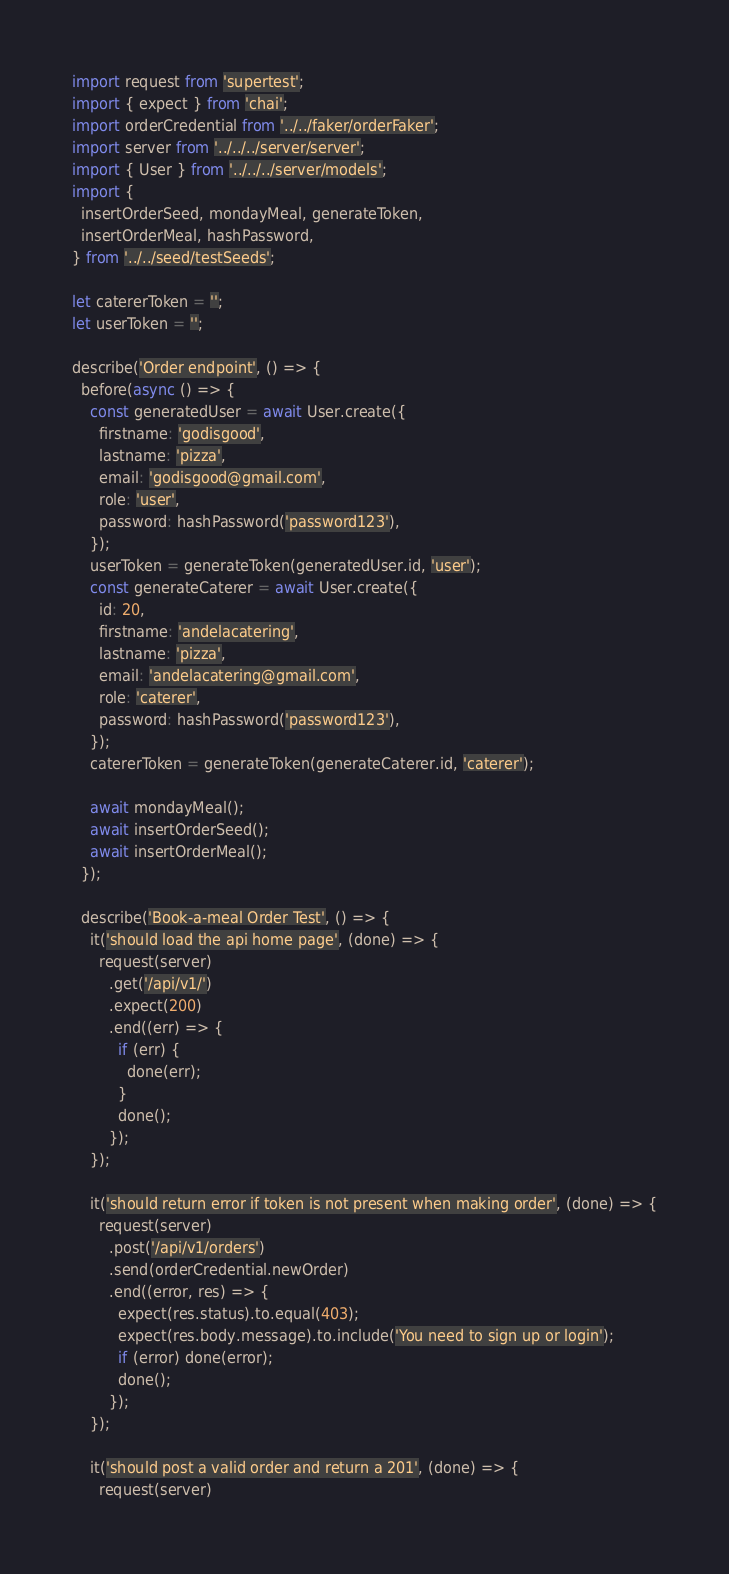<code> <loc_0><loc_0><loc_500><loc_500><_JavaScript_>import request from 'supertest';
import { expect } from 'chai';
import orderCredential from '../../faker/orderFaker';
import server from '../../../server/server';
import { User } from '../../../server/models';
import {
  insertOrderSeed, mondayMeal, generateToken,
  insertOrderMeal, hashPassword,
} from '../../seed/testSeeds';

let catererToken = '';
let userToken = '';

describe('Order endpoint', () => {
  before(async () => {
    const generatedUser = await User.create({
      firstname: 'godisgood',
      lastname: 'pizza',
      email: 'godisgood@gmail.com',
      role: 'user',
      password: hashPassword('password123'),
    });
    userToken = generateToken(generatedUser.id, 'user');
    const generateCaterer = await User.create({
      id: 20,
      firstname: 'andelacatering',
      lastname: 'pizza',
      email: 'andelacatering@gmail.com',
      role: 'caterer',
      password: hashPassword('password123'),
    });
    catererToken = generateToken(generateCaterer.id, 'caterer');

    await mondayMeal();
    await insertOrderSeed();
    await insertOrderMeal();
  });

  describe('Book-a-meal Order Test', () => {
    it('should load the api home page', (done) => {
      request(server)
        .get('/api/v1/')
        .expect(200)
        .end((err) => {
          if (err) {
            done(err);
          }
          done();
        });
    });

    it('should return error if token is not present when making order', (done) => {
      request(server)
        .post('/api/v1/orders')
        .send(orderCredential.newOrder)
        .end((error, res) => {
          expect(res.status).to.equal(403);
          expect(res.body.message).to.include('You need to sign up or login');
          if (error) done(error);
          done();
        });
    });

    it('should post a valid order and return a 201', (done) => {
      request(server)</code> 